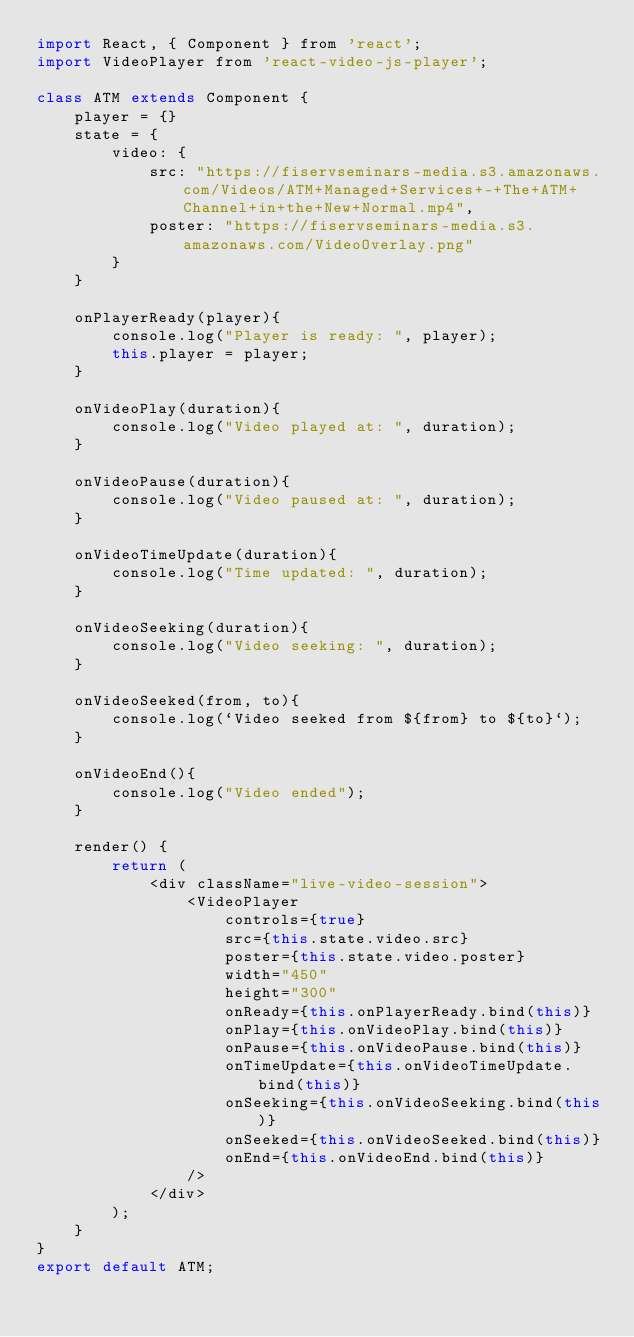Convert code to text. <code><loc_0><loc_0><loc_500><loc_500><_JavaScript_>import React, { Component } from 'react';
import VideoPlayer from 'react-video-js-player';
 
class ATM extends Component {
    player = {}
    state = {
        video: {
            src: "https://fiservseminars-media.s3.amazonaws.com/Videos/ATM+Managed+Services+-+The+ATM+Channel+in+the+New+Normal.mp4",
            poster: "https://fiservseminars-media.s3.amazonaws.com/VideoOverlay.png"
        }
    }
 
    onPlayerReady(player){
        console.log("Player is ready: ", player);
        this.player = player;
    }
 
    onVideoPlay(duration){
        console.log("Video played at: ", duration);
    }
 
    onVideoPause(duration){
        console.log("Video paused at: ", duration);
    }
 
    onVideoTimeUpdate(duration){
        console.log("Time updated: ", duration);
    }
 
    onVideoSeeking(duration){
        console.log("Video seeking: ", duration);
    }
 
    onVideoSeeked(from, to){
        console.log(`Video seeked from ${from} to ${to}`);
    }
 
    onVideoEnd(){
        console.log("Video ended");
    }
 
    render() {
        return (
            <div className="live-video-session">
                <VideoPlayer
                    controls={true}
                    src={this.state.video.src}
                    poster={this.state.video.poster}
                    width="450"
                    height="300"
                    onReady={this.onPlayerReady.bind(this)}
                    onPlay={this.onVideoPlay.bind(this)}
                    onPause={this.onVideoPause.bind(this)}
                    onTimeUpdate={this.onVideoTimeUpdate.bind(this)}
                    onSeeking={this.onVideoSeeking.bind(this)}
                    onSeeked={this.onVideoSeeked.bind(this)}
                    onEnd={this.onVideoEnd.bind(this)}
                />
            </div>
        );
    }
}
export default ATM;</code> 